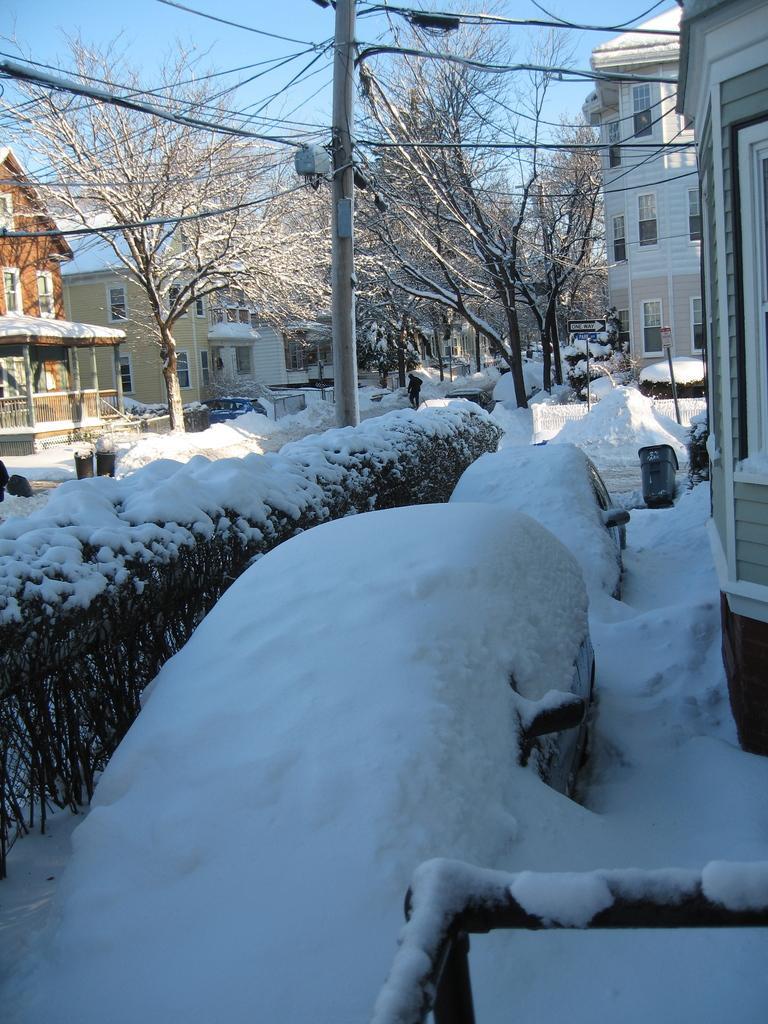Please provide a concise description of this image. In this image there are buildings and trees. At the bottom there is snow. In the background there are wires and sky. There is a pole. 